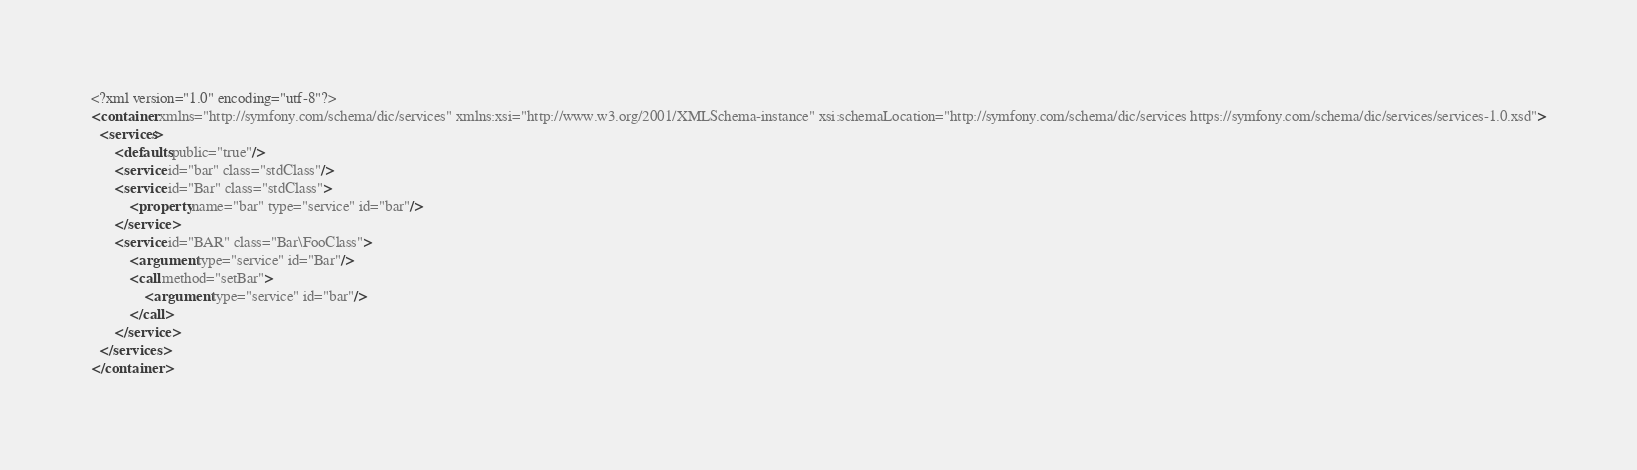<code> <loc_0><loc_0><loc_500><loc_500><_XML_><?xml version="1.0" encoding="utf-8"?>
<container xmlns="http://symfony.com/schema/dic/services" xmlns:xsi="http://www.w3.org/2001/XMLSchema-instance" xsi:schemaLocation="http://symfony.com/schema/dic/services https://symfony.com/schema/dic/services/services-1.0.xsd">
  <services>
      <defaults public="true"/>
      <service id="bar" class="stdClass"/>
      <service id="Bar" class="stdClass">
          <property name="bar" type="service" id="bar"/>
      </service>
      <service id="BAR" class="Bar\FooClass">
          <argument type="service" id="Bar"/>
          <call method="setBar">
              <argument type="service" id="bar"/>
          </call>
      </service>
  </services>
</container>
</code> 